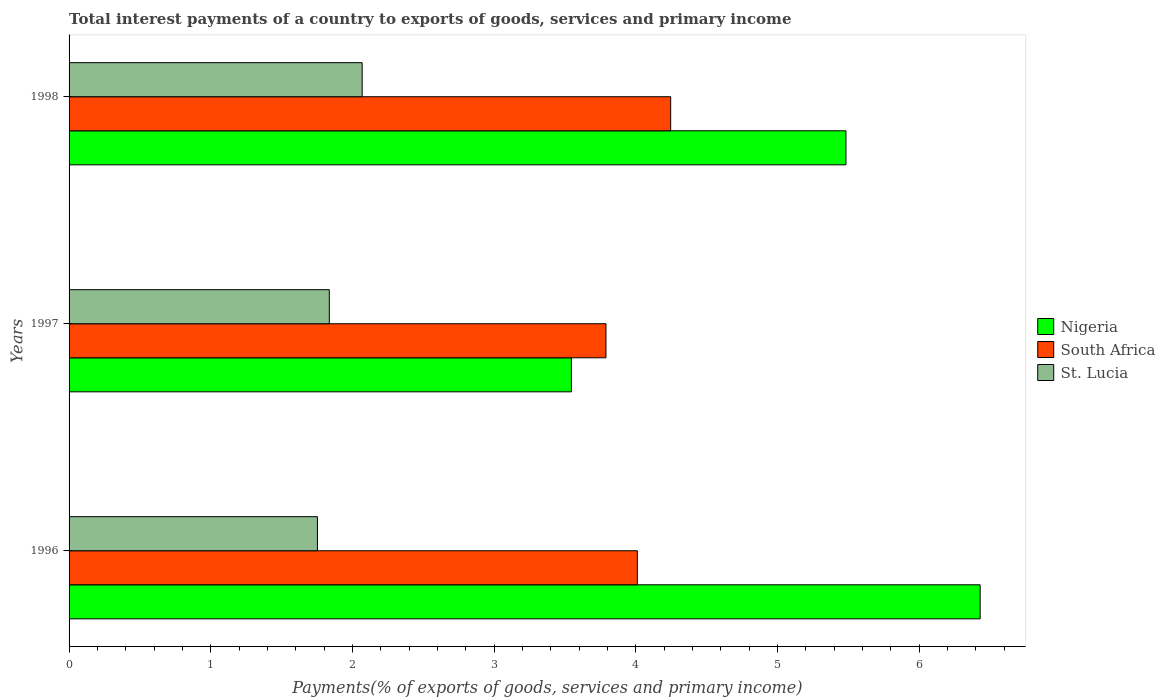Are the number of bars per tick equal to the number of legend labels?
Offer a very short reply. Yes. Are the number of bars on each tick of the Y-axis equal?
Keep it short and to the point. Yes. How many bars are there on the 2nd tick from the top?
Your response must be concise. 3. How many bars are there on the 3rd tick from the bottom?
Your response must be concise. 3. What is the label of the 2nd group of bars from the top?
Your answer should be very brief. 1997. What is the total interest payments in St. Lucia in 1998?
Keep it short and to the point. 2.07. Across all years, what is the maximum total interest payments in South Africa?
Offer a very short reply. 4.25. Across all years, what is the minimum total interest payments in Nigeria?
Keep it short and to the point. 3.55. What is the total total interest payments in South Africa in the graph?
Provide a succinct answer. 12.05. What is the difference between the total interest payments in South Africa in 1997 and that in 1998?
Ensure brevity in your answer.  -0.46. What is the difference between the total interest payments in St. Lucia in 1997 and the total interest payments in Nigeria in 1998?
Keep it short and to the point. -3.65. What is the average total interest payments in Nigeria per year?
Ensure brevity in your answer.  5.15. In the year 1997, what is the difference between the total interest payments in Nigeria and total interest payments in St. Lucia?
Provide a short and direct response. 1.71. In how many years, is the total interest payments in South Africa greater than 4 %?
Ensure brevity in your answer.  2. What is the ratio of the total interest payments in South Africa in 1996 to that in 1998?
Ensure brevity in your answer.  0.94. Is the total interest payments in Nigeria in 1997 less than that in 1998?
Give a very brief answer. Yes. What is the difference between the highest and the second highest total interest payments in St. Lucia?
Your response must be concise. 0.23. What is the difference between the highest and the lowest total interest payments in South Africa?
Ensure brevity in your answer.  0.46. In how many years, is the total interest payments in Nigeria greater than the average total interest payments in Nigeria taken over all years?
Your answer should be compact. 2. Is the sum of the total interest payments in St. Lucia in 1996 and 1998 greater than the maximum total interest payments in Nigeria across all years?
Provide a succinct answer. No. What does the 3rd bar from the top in 1998 represents?
Make the answer very short. Nigeria. What does the 1st bar from the bottom in 1997 represents?
Your response must be concise. Nigeria. Is it the case that in every year, the sum of the total interest payments in South Africa and total interest payments in Nigeria is greater than the total interest payments in St. Lucia?
Offer a very short reply. Yes. Are all the bars in the graph horizontal?
Ensure brevity in your answer.  Yes. Are the values on the major ticks of X-axis written in scientific E-notation?
Your answer should be compact. No. Does the graph contain any zero values?
Provide a short and direct response. No. Does the graph contain grids?
Offer a terse response. No. Where does the legend appear in the graph?
Offer a very short reply. Center right. How are the legend labels stacked?
Ensure brevity in your answer.  Vertical. What is the title of the graph?
Your response must be concise. Total interest payments of a country to exports of goods, services and primary income. What is the label or title of the X-axis?
Offer a terse response. Payments(% of exports of goods, services and primary income). What is the Payments(% of exports of goods, services and primary income) in Nigeria in 1996?
Keep it short and to the point. 6.43. What is the Payments(% of exports of goods, services and primary income) of South Africa in 1996?
Make the answer very short. 4.01. What is the Payments(% of exports of goods, services and primary income) of St. Lucia in 1996?
Your response must be concise. 1.75. What is the Payments(% of exports of goods, services and primary income) of Nigeria in 1997?
Keep it short and to the point. 3.55. What is the Payments(% of exports of goods, services and primary income) of South Africa in 1997?
Offer a terse response. 3.79. What is the Payments(% of exports of goods, services and primary income) in St. Lucia in 1997?
Keep it short and to the point. 1.84. What is the Payments(% of exports of goods, services and primary income) in Nigeria in 1998?
Provide a short and direct response. 5.48. What is the Payments(% of exports of goods, services and primary income) of South Africa in 1998?
Make the answer very short. 4.25. What is the Payments(% of exports of goods, services and primary income) of St. Lucia in 1998?
Keep it short and to the point. 2.07. Across all years, what is the maximum Payments(% of exports of goods, services and primary income) in Nigeria?
Make the answer very short. 6.43. Across all years, what is the maximum Payments(% of exports of goods, services and primary income) of South Africa?
Provide a succinct answer. 4.25. Across all years, what is the maximum Payments(% of exports of goods, services and primary income) in St. Lucia?
Provide a short and direct response. 2.07. Across all years, what is the minimum Payments(% of exports of goods, services and primary income) of Nigeria?
Your response must be concise. 3.55. Across all years, what is the minimum Payments(% of exports of goods, services and primary income) of South Africa?
Your response must be concise. 3.79. Across all years, what is the minimum Payments(% of exports of goods, services and primary income) of St. Lucia?
Your answer should be very brief. 1.75. What is the total Payments(% of exports of goods, services and primary income) of Nigeria in the graph?
Provide a short and direct response. 15.46. What is the total Payments(% of exports of goods, services and primary income) in South Africa in the graph?
Your answer should be very brief. 12.05. What is the total Payments(% of exports of goods, services and primary income) of St. Lucia in the graph?
Ensure brevity in your answer.  5.66. What is the difference between the Payments(% of exports of goods, services and primary income) of Nigeria in 1996 and that in 1997?
Ensure brevity in your answer.  2.89. What is the difference between the Payments(% of exports of goods, services and primary income) in South Africa in 1996 and that in 1997?
Your response must be concise. 0.22. What is the difference between the Payments(% of exports of goods, services and primary income) in St. Lucia in 1996 and that in 1997?
Provide a succinct answer. -0.08. What is the difference between the Payments(% of exports of goods, services and primary income) of Nigeria in 1996 and that in 1998?
Offer a very short reply. 0.95. What is the difference between the Payments(% of exports of goods, services and primary income) of South Africa in 1996 and that in 1998?
Ensure brevity in your answer.  -0.24. What is the difference between the Payments(% of exports of goods, services and primary income) in St. Lucia in 1996 and that in 1998?
Keep it short and to the point. -0.32. What is the difference between the Payments(% of exports of goods, services and primary income) of Nigeria in 1997 and that in 1998?
Ensure brevity in your answer.  -1.94. What is the difference between the Payments(% of exports of goods, services and primary income) of South Africa in 1997 and that in 1998?
Your answer should be very brief. -0.46. What is the difference between the Payments(% of exports of goods, services and primary income) in St. Lucia in 1997 and that in 1998?
Make the answer very short. -0.23. What is the difference between the Payments(% of exports of goods, services and primary income) of Nigeria in 1996 and the Payments(% of exports of goods, services and primary income) of South Africa in 1997?
Give a very brief answer. 2.64. What is the difference between the Payments(% of exports of goods, services and primary income) in Nigeria in 1996 and the Payments(% of exports of goods, services and primary income) in St. Lucia in 1997?
Your answer should be compact. 4.59. What is the difference between the Payments(% of exports of goods, services and primary income) in South Africa in 1996 and the Payments(% of exports of goods, services and primary income) in St. Lucia in 1997?
Give a very brief answer. 2.17. What is the difference between the Payments(% of exports of goods, services and primary income) in Nigeria in 1996 and the Payments(% of exports of goods, services and primary income) in South Africa in 1998?
Your answer should be compact. 2.18. What is the difference between the Payments(% of exports of goods, services and primary income) in Nigeria in 1996 and the Payments(% of exports of goods, services and primary income) in St. Lucia in 1998?
Your response must be concise. 4.36. What is the difference between the Payments(% of exports of goods, services and primary income) of South Africa in 1996 and the Payments(% of exports of goods, services and primary income) of St. Lucia in 1998?
Provide a short and direct response. 1.94. What is the difference between the Payments(% of exports of goods, services and primary income) in Nigeria in 1997 and the Payments(% of exports of goods, services and primary income) in South Africa in 1998?
Provide a short and direct response. -0.7. What is the difference between the Payments(% of exports of goods, services and primary income) in Nigeria in 1997 and the Payments(% of exports of goods, services and primary income) in St. Lucia in 1998?
Provide a short and direct response. 1.48. What is the difference between the Payments(% of exports of goods, services and primary income) of South Africa in 1997 and the Payments(% of exports of goods, services and primary income) of St. Lucia in 1998?
Provide a succinct answer. 1.72. What is the average Payments(% of exports of goods, services and primary income) of Nigeria per year?
Your answer should be very brief. 5.15. What is the average Payments(% of exports of goods, services and primary income) of South Africa per year?
Give a very brief answer. 4.02. What is the average Payments(% of exports of goods, services and primary income) in St. Lucia per year?
Offer a very short reply. 1.89. In the year 1996, what is the difference between the Payments(% of exports of goods, services and primary income) in Nigeria and Payments(% of exports of goods, services and primary income) in South Africa?
Make the answer very short. 2.42. In the year 1996, what is the difference between the Payments(% of exports of goods, services and primary income) of Nigeria and Payments(% of exports of goods, services and primary income) of St. Lucia?
Your answer should be compact. 4.68. In the year 1996, what is the difference between the Payments(% of exports of goods, services and primary income) of South Africa and Payments(% of exports of goods, services and primary income) of St. Lucia?
Offer a very short reply. 2.26. In the year 1997, what is the difference between the Payments(% of exports of goods, services and primary income) of Nigeria and Payments(% of exports of goods, services and primary income) of South Africa?
Offer a very short reply. -0.24. In the year 1997, what is the difference between the Payments(% of exports of goods, services and primary income) of Nigeria and Payments(% of exports of goods, services and primary income) of St. Lucia?
Provide a succinct answer. 1.71. In the year 1997, what is the difference between the Payments(% of exports of goods, services and primary income) in South Africa and Payments(% of exports of goods, services and primary income) in St. Lucia?
Keep it short and to the point. 1.95. In the year 1998, what is the difference between the Payments(% of exports of goods, services and primary income) of Nigeria and Payments(% of exports of goods, services and primary income) of South Africa?
Provide a short and direct response. 1.24. In the year 1998, what is the difference between the Payments(% of exports of goods, services and primary income) of Nigeria and Payments(% of exports of goods, services and primary income) of St. Lucia?
Provide a short and direct response. 3.41. In the year 1998, what is the difference between the Payments(% of exports of goods, services and primary income) in South Africa and Payments(% of exports of goods, services and primary income) in St. Lucia?
Provide a short and direct response. 2.18. What is the ratio of the Payments(% of exports of goods, services and primary income) in Nigeria in 1996 to that in 1997?
Make the answer very short. 1.81. What is the ratio of the Payments(% of exports of goods, services and primary income) in South Africa in 1996 to that in 1997?
Make the answer very short. 1.06. What is the ratio of the Payments(% of exports of goods, services and primary income) of St. Lucia in 1996 to that in 1997?
Your answer should be compact. 0.95. What is the ratio of the Payments(% of exports of goods, services and primary income) in Nigeria in 1996 to that in 1998?
Your response must be concise. 1.17. What is the ratio of the Payments(% of exports of goods, services and primary income) of South Africa in 1996 to that in 1998?
Offer a very short reply. 0.94. What is the ratio of the Payments(% of exports of goods, services and primary income) in St. Lucia in 1996 to that in 1998?
Offer a very short reply. 0.85. What is the ratio of the Payments(% of exports of goods, services and primary income) in Nigeria in 1997 to that in 1998?
Make the answer very short. 0.65. What is the ratio of the Payments(% of exports of goods, services and primary income) in South Africa in 1997 to that in 1998?
Make the answer very short. 0.89. What is the ratio of the Payments(% of exports of goods, services and primary income) in St. Lucia in 1997 to that in 1998?
Your answer should be very brief. 0.89. What is the difference between the highest and the second highest Payments(% of exports of goods, services and primary income) in Nigeria?
Make the answer very short. 0.95. What is the difference between the highest and the second highest Payments(% of exports of goods, services and primary income) in South Africa?
Offer a terse response. 0.24. What is the difference between the highest and the second highest Payments(% of exports of goods, services and primary income) of St. Lucia?
Your answer should be compact. 0.23. What is the difference between the highest and the lowest Payments(% of exports of goods, services and primary income) in Nigeria?
Your answer should be compact. 2.89. What is the difference between the highest and the lowest Payments(% of exports of goods, services and primary income) of South Africa?
Provide a succinct answer. 0.46. What is the difference between the highest and the lowest Payments(% of exports of goods, services and primary income) of St. Lucia?
Ensure brevity in your answer.  0.32. 